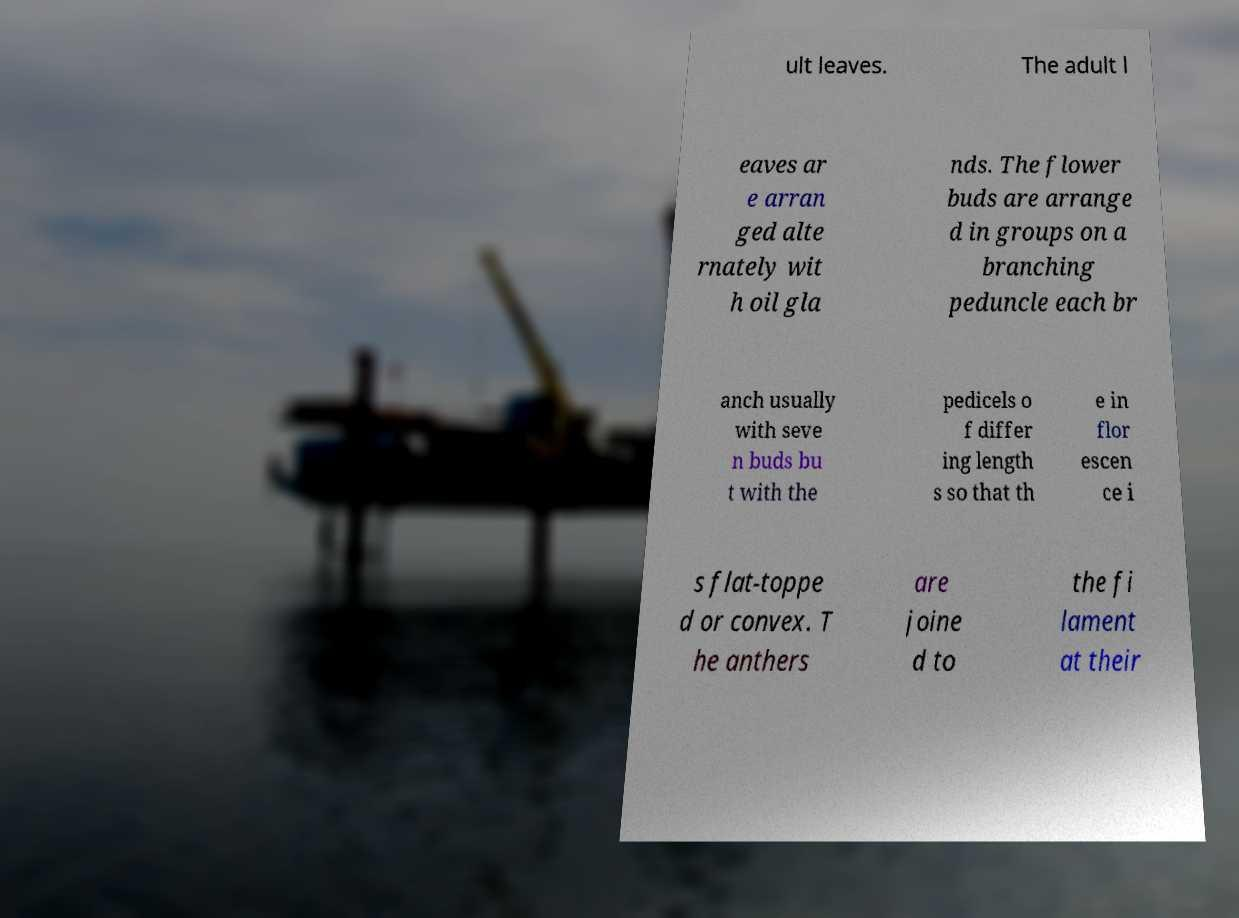What messages or text are displayed in this image? I need them in a readable, typed format. ult leaves. The adult l eaves ar e arran ged alte rnately wit h oil gla nds. The flower buds are arrange d in groups on a branching peduncle each br anch usually with seve n buds bu t with the pedicels o f differ ing length s so that th e in flor escen ce i s flat-toppe d or convex. T he anthers are joine d to the fi lament at their 